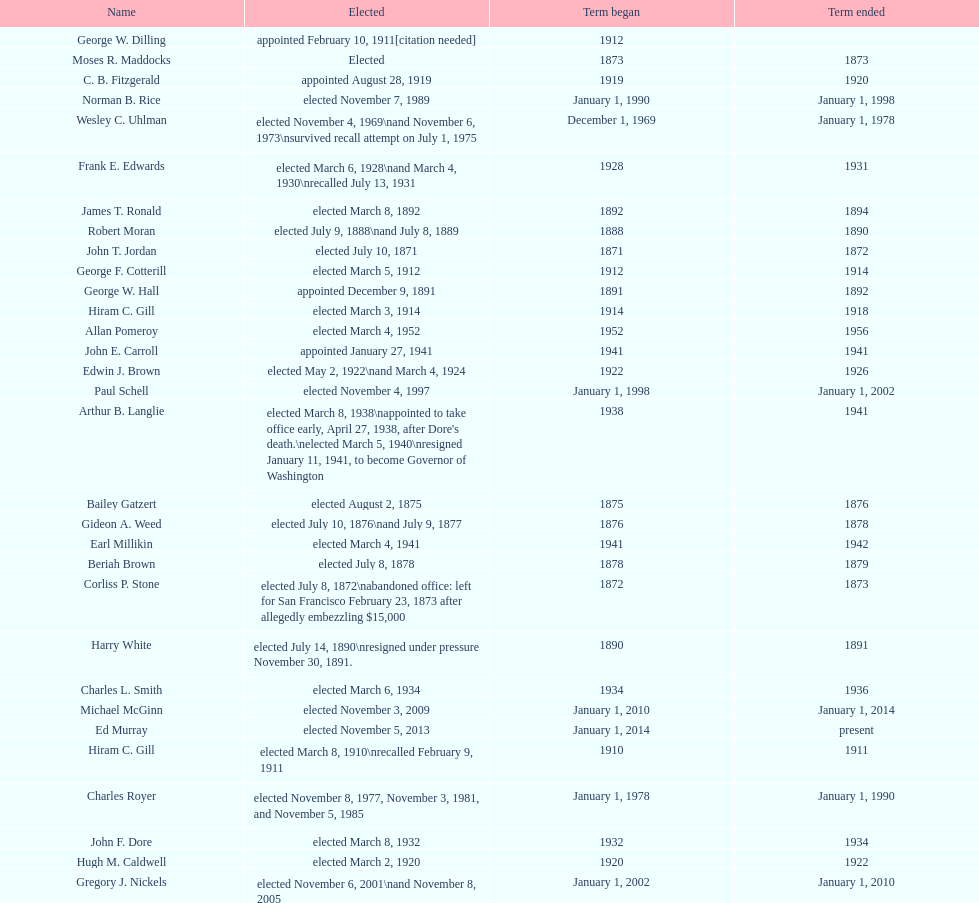What is the number of mayors with the first name of john? 6. 